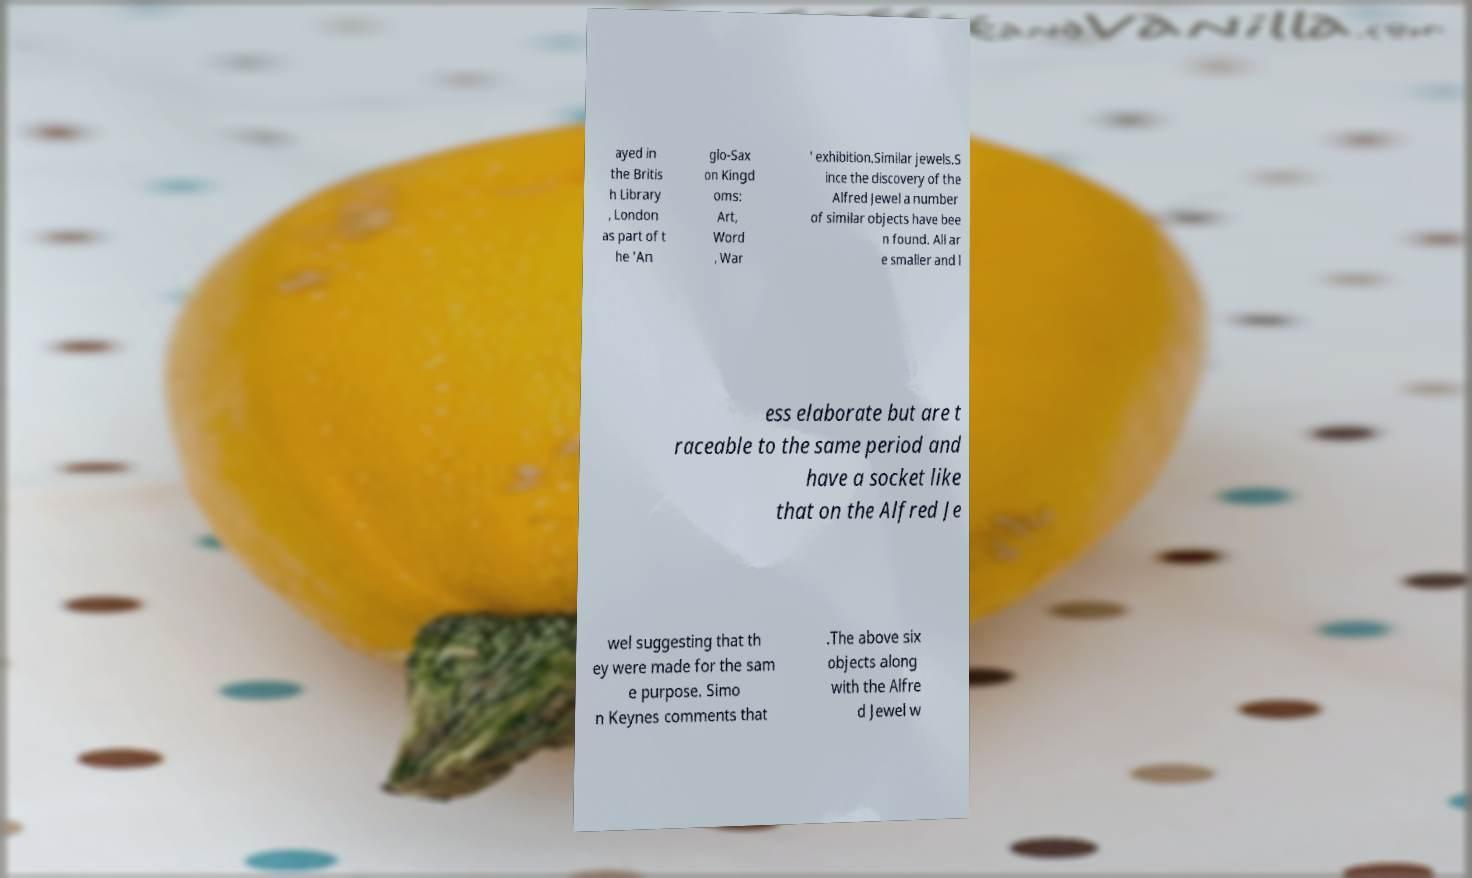There's text embedded in this image that I need extracted. Can you transcribe it verbatim? ayed in the Britis h Library , London as part of t he 'An glo-Sax on Kingd oms: Art, Word , War ' exhibition.Similar jewels.S ince the discovery of the Alfred Jewel a number of similar objects have bee n found. All ar e smaller and l ess elaborate but are t raceable to the same period and have a socket like that on the Alfred Je wel suggesting that th ey were made for the sam e purpose. Simo n Keynes comments that .The above six objects along with the Alfre d Jewel w 